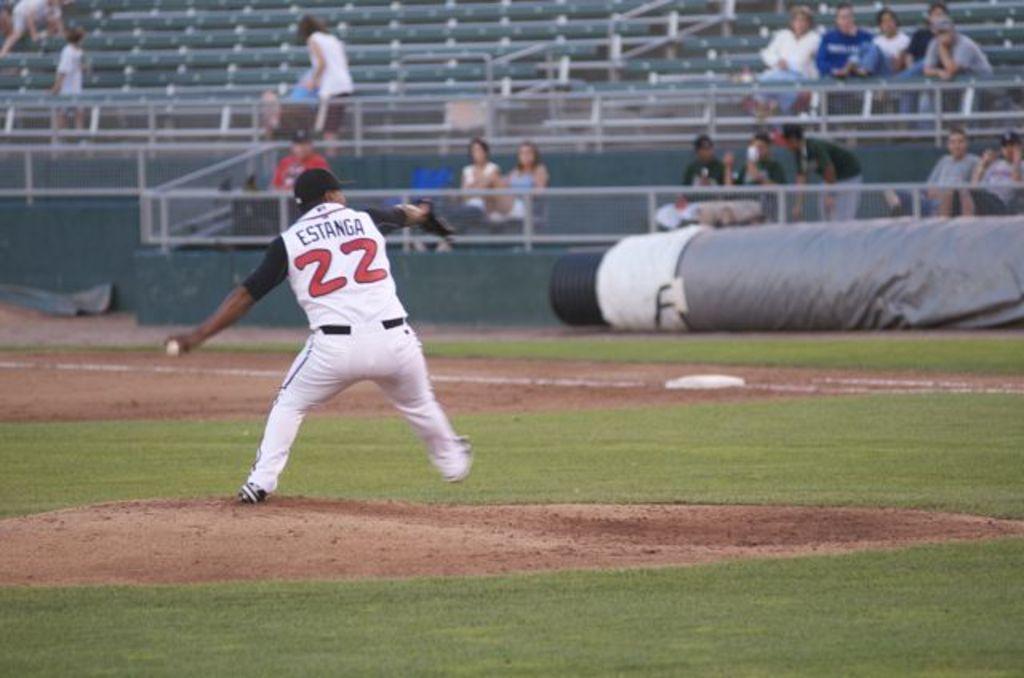What is the pitcher's player number?
Make the answer very short. 22. 